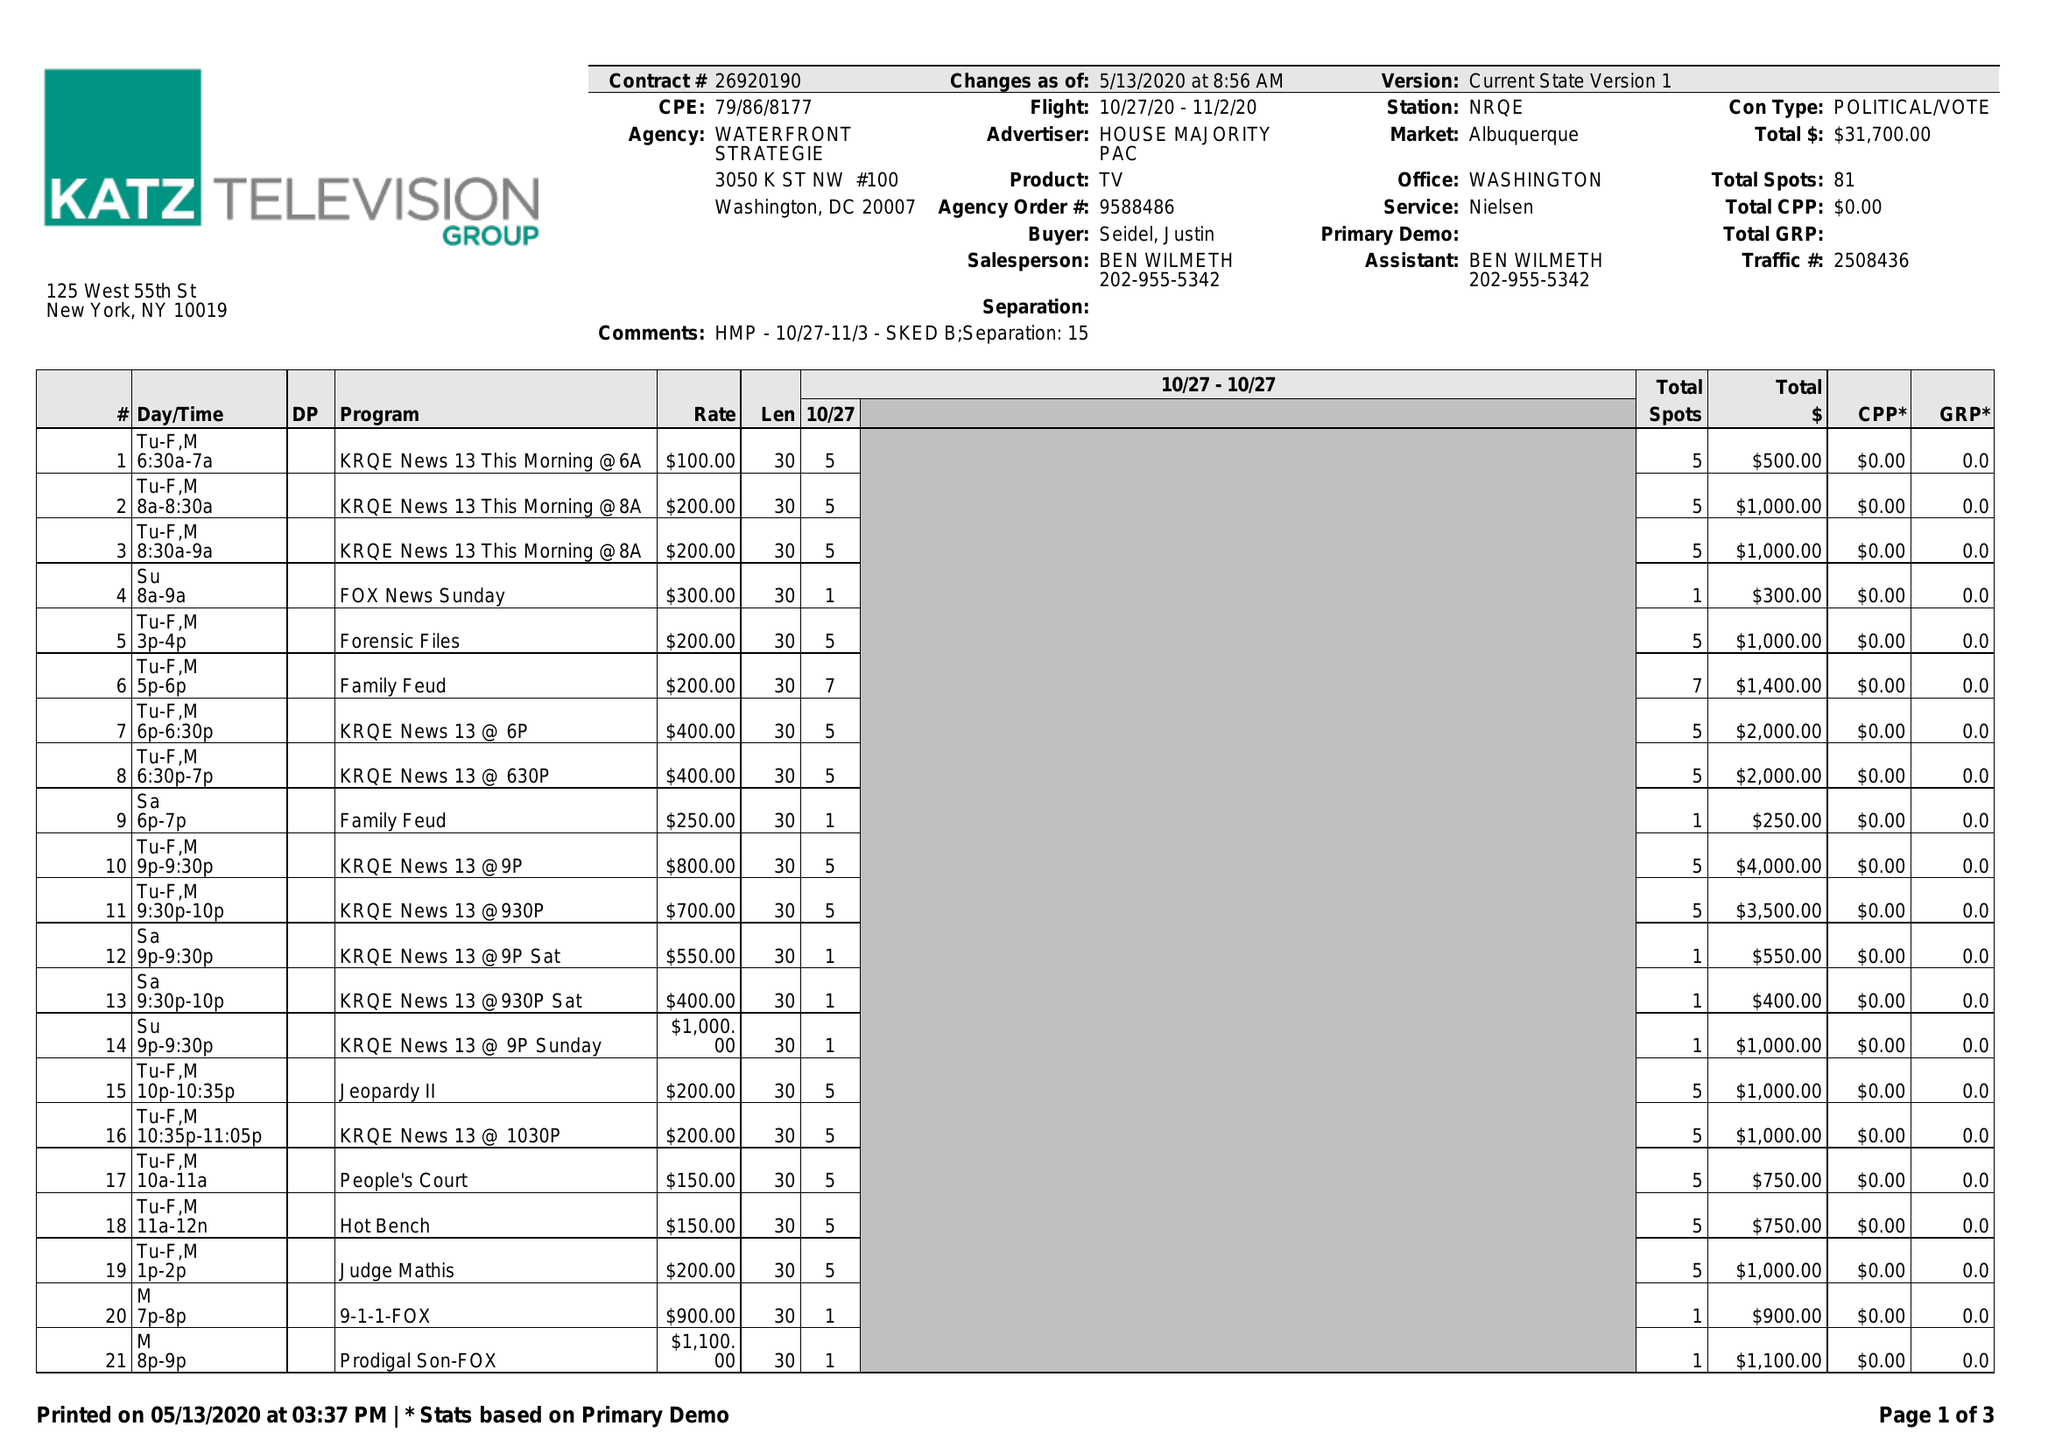What is the value for the flight_from?
Answer the question using a single word or phrase. 10/27/20 